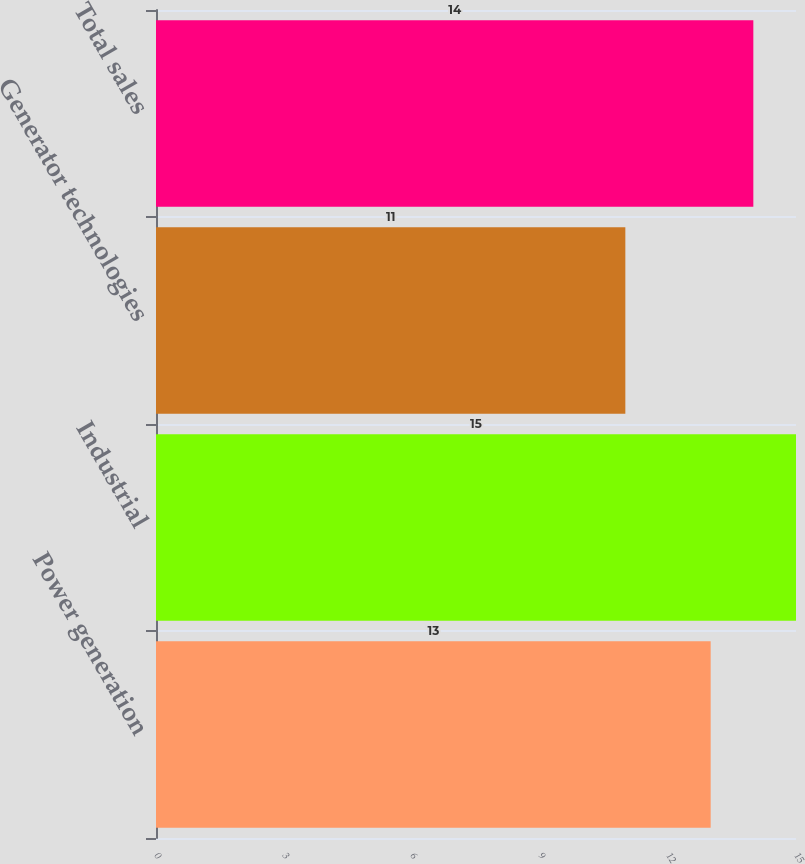Convert chart. <chart><loc_0><loc_0><loc_500><loc_500><bar_chart><fcel>Power generation<fcel>Industrial<fcel>Generator technologies<fcel>Total sales<nl><fcel>13<fcel>15<fcel>11<fcel>14<nl></chart> 